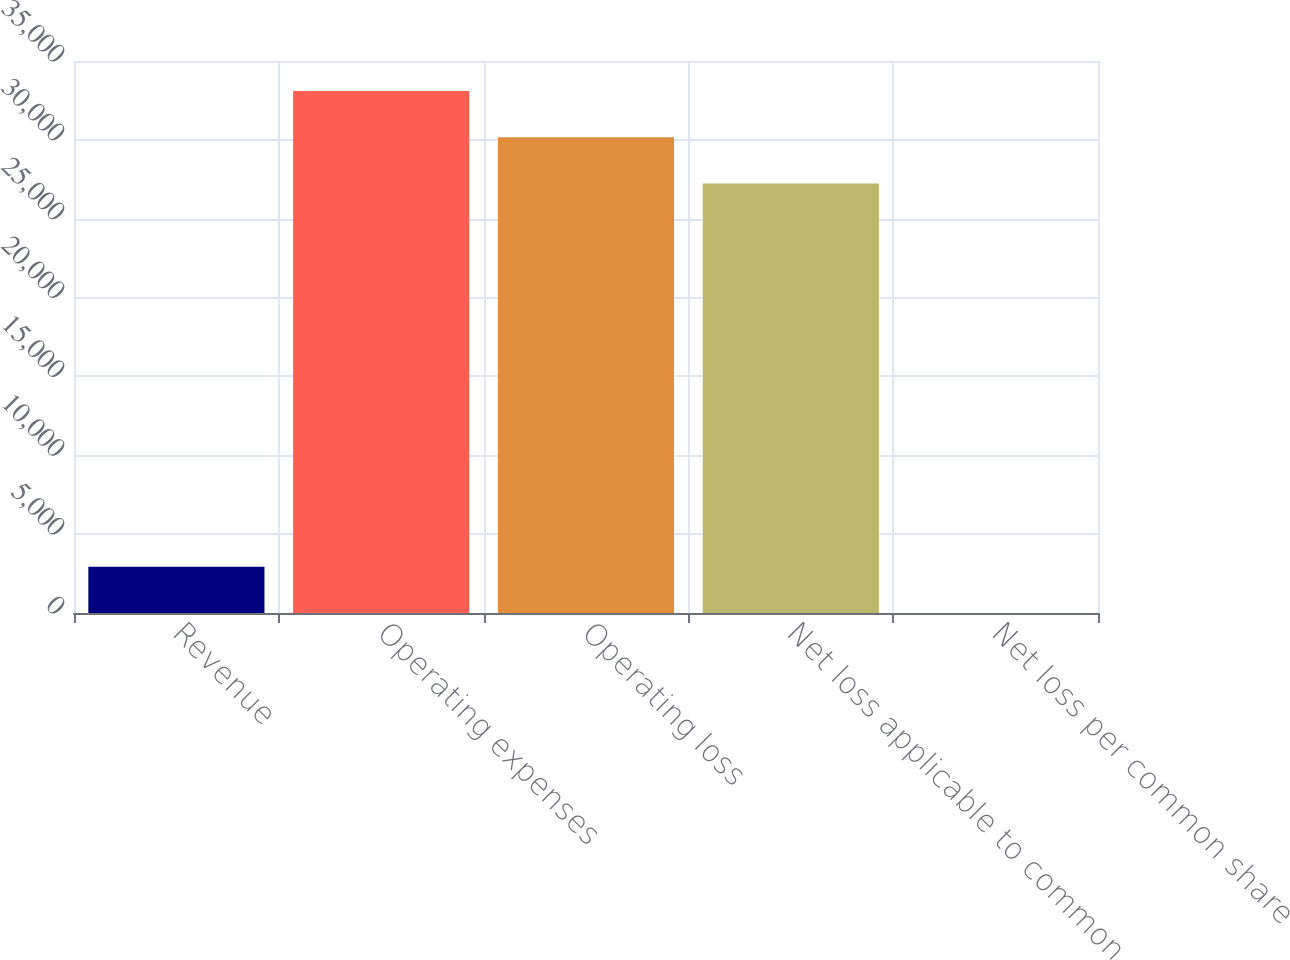Convert chart. <chart><loc_0><loc_0><loc_500><loc_500><bar_chart><fcel>Revenue<fcel>Operating expenses<fcel>Operating loss<fcel>Net loss applicable to common<fcel>Net loss per common share<nl><fcel>2936.69<fcel>33097.6<fcel>30161.8<fcel>27226<fcel>0.88<nl></chart> 